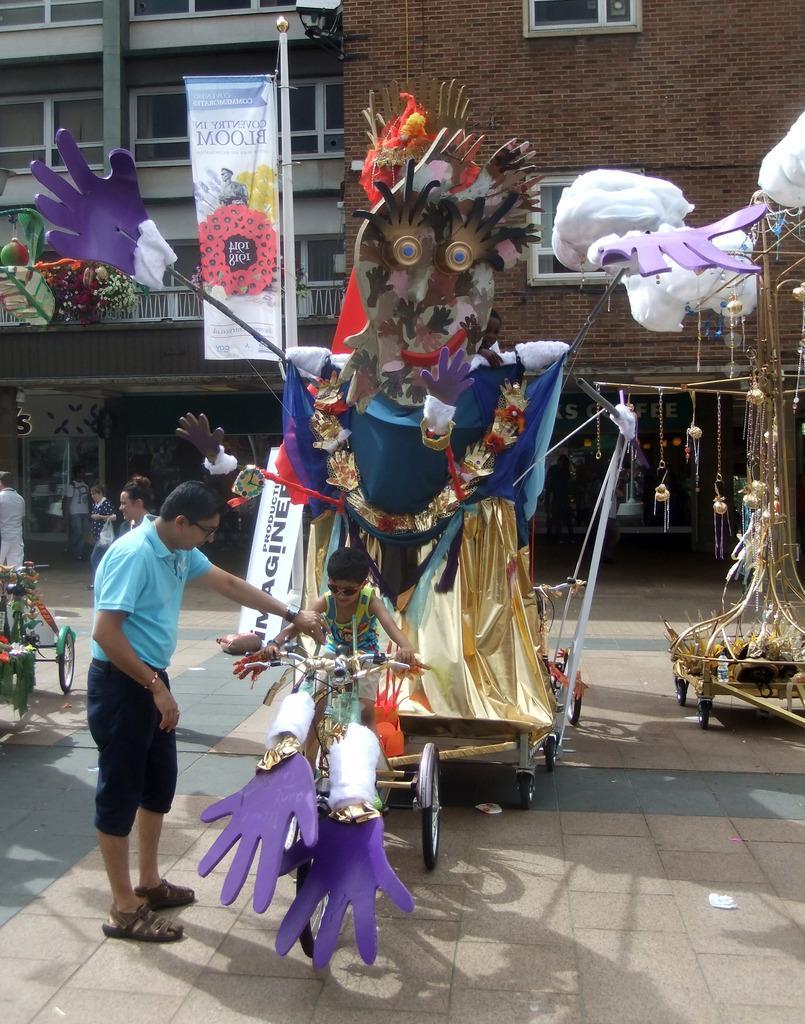In one or two sentences, can you explain what this image depicts? In this picture we can see a boy is sitting on a bicycle and on the left side of the boy there is a man standing on the path. Behind the kid there are some decorative items and some people are walking on the path. Behind the people there is a banner to the pole and a building. 